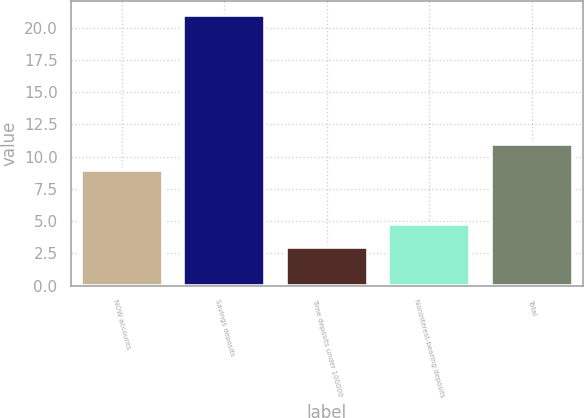<chart> <loc_0><loc_0><loc_500><loc_500><bar_chart><fcel>NOW accounts<fcel>Savings deposits<fcel>Time deposits under 100000<fcel>Noninterest-bearing deposits<fcel>Total<nl><fcel>9<fcel>21<fcel>3<fcel>4.8<fcel>11<nl></chart> 